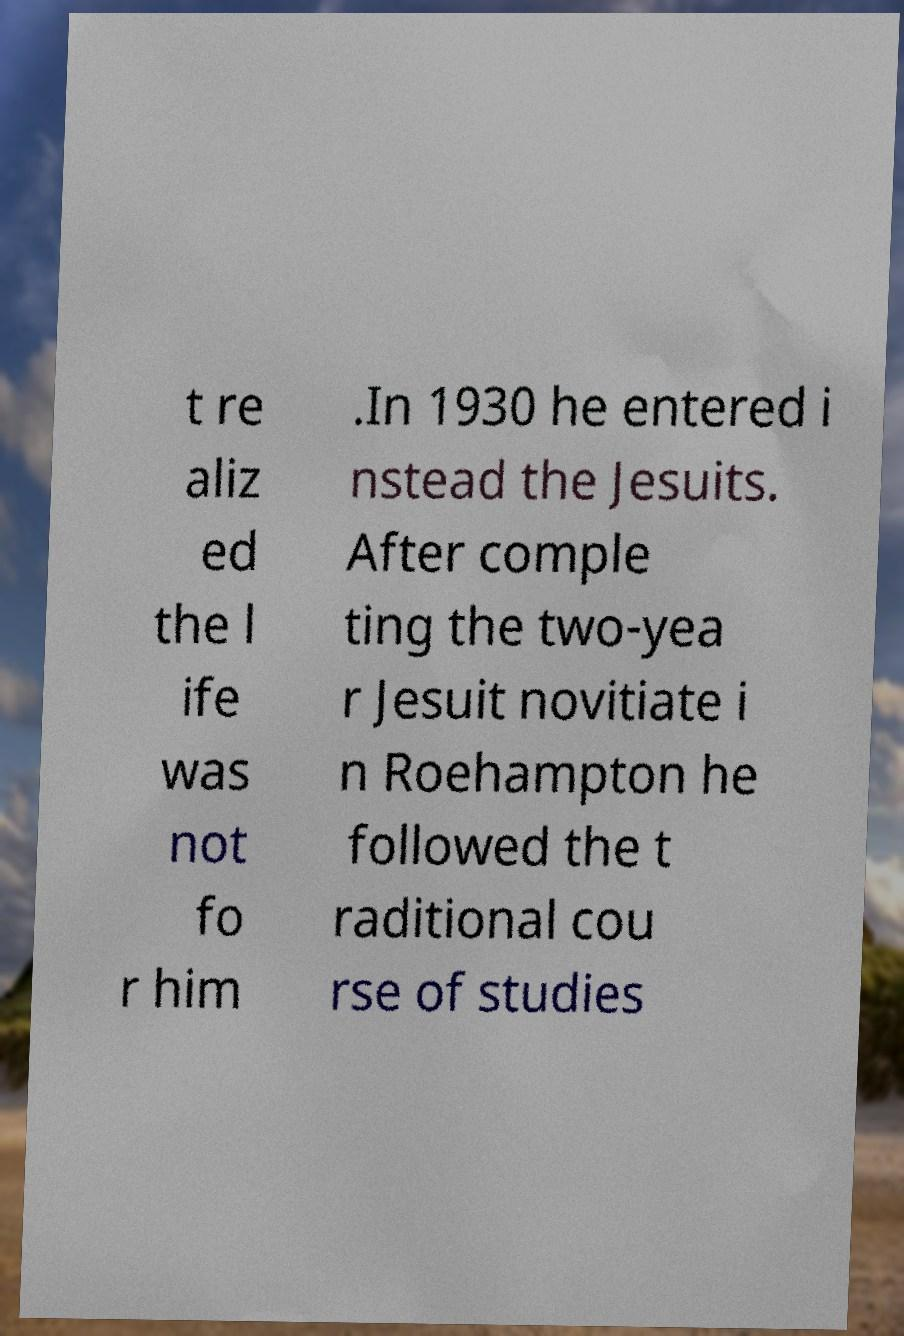Please identify and transcribe the text found in this image. t re aliz ed the l ife was not fo r him .In 1930 he entered i nstead the Jesuits. After comple ting the two-yea r Jesuit novitiate i n Roehampton he followed the t raditional cou rse of studies 